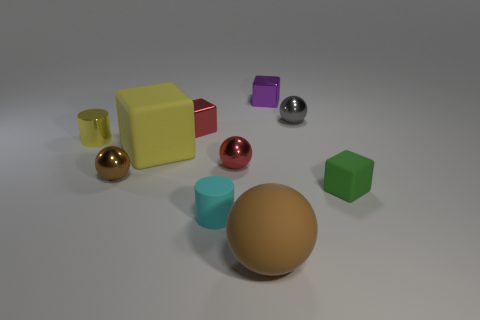Subtract 1 blocks. How many blocks are left? 3 Subtract all cyan balls. Subtract all red cylinders. How many balls are left? 4 Subtract all cubes. How many objects are left? 6 Add 10 tiny cyan balls. How many tiny cyan balls exist? 10 Subtract 0 blue cylinders. How many objects are left? 10 Subtract all small gray shiny balls. Subtract all large rubber cubes. How many objects are left? 8 Add 3 tiny green rubber blocks. How many tiny green rubber blocks are left? 4 